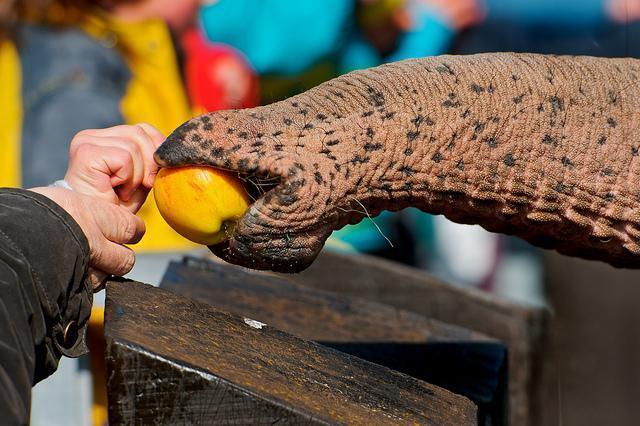How many people are visible?
Give a very brief answer. 2. 